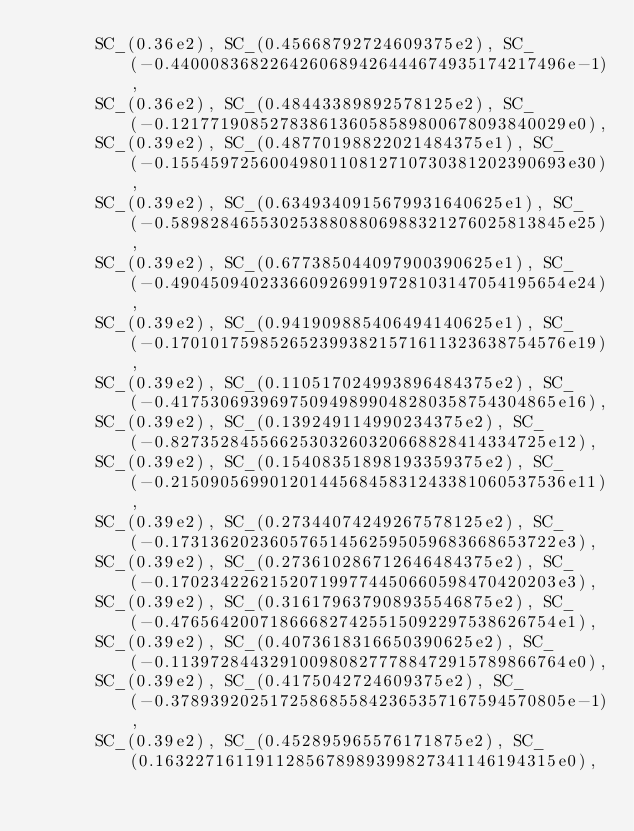<code> <loc_0><loc_0><loc_500><loc_500><_C++_>      SC_(0.36e2), SC_(0.45668792724609375e2), SC_(-0.4400083682264260689426444674935174217496e-1), 
      SC_(0.36e2), SC_(0.48443389892578125e2), SC_(-0.1217719085278386136058589800678093840029e0), 
      SC_(0.39e2), SC_(0.48770198822021484375e1), SC_(-0.1554597256004980110812710730381202390693e30), 
      SC_(0.39e2), SC_(0.6349340915679931640625e1), SC_(-0.5898284655302538808806988321276025813845e25), 
      SC_(0.39e2), SC_(0.677385044097900390625e1), SC_(-0.4904509402336609269919728103147054195654e24), 
      SC_(0.39e2), SC_(0.941909885406494140625e1), SC_(-0.1701017598526523993821571611323638754576e19), 
      SC_(0.39e2), SC_(0.110517024993896484375e2), SC_(-0.417530693969750949899048280358754304865e16), 
      SC_(0.39e2), SC_(0.139249114990234375e2), SC_(-0.82735284556625303260320668828414334725e12), 
      SC_(0.39e2), SC_(0.15408351898193359375e2), SC_(-0.2150905699012014456845831243381060537536e11), 
      SC_(0.39e2), SC_(0.27344074249267578125e2), SC_(-0.173136202360576514562595059683668653722e3), 
      SC_(0.39e2), SC_(0.273610286712646484375e2), SC_(-0.170234226215207199774450660598470420203e3), 
      SC_(0.39e2), SC_(0.316179637908935546875e2), SC_(-0.476564200718666827425515092297538626754e1), 
      SC_(0.39e2), SC_(0.4073618316650390625e2), SC_(-0.1139728443291009808277788472915789866764e0), 
      SC_(0.39e2), SC_(0.4175042724609375e2), SC_(-0.3789392025172586855842365357167594570805e-1), 
      SC_(0.39e2), SC_(0.452895965576171875e2), SC_(0.1632271611911285678989399827341146194315e0), </code> 